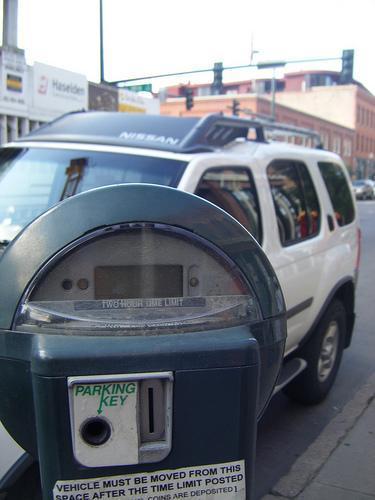How many meters are there?
Give a very brief answer. 1. 